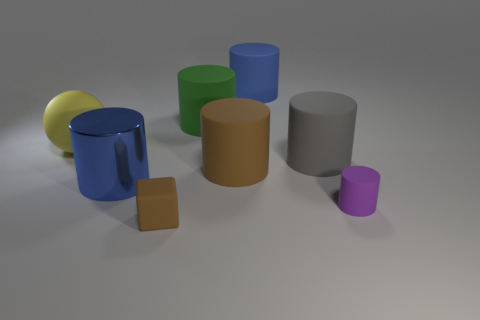Do the tiny rubber object that is on the left side of the gray rubber cylinder and the big rubber object that is in front of the big gray rubber cylinder have the same color?
Give a very brief answer. Yes. What is the material of the gray thing in front of the blue thing behind the blue thing in front of the large blue matte thing?
Provide a succinct answer. Rubber. Are there more shiny things than tiny green rubber spheres?
Keep it short and to the point. Yes. Is there any other thing of the same color as the large metallic object?
Ensure brevity in your answer.  Yes. What size is the purple cylinder that is made of the same material as the green object?
Your answer should be very brief. Small. What material is the large gray cylinder?
Provide a short and direct response. Rubber. What number of green matte things are the same size as the blue rubber cylinder?
Your answer should be compact. 1. The thing that is the same color as the shiny cylinder is what shape?
Provide a short and direct response. Cylinder. Are there any blue objects of the same shape as the green matte object?
Offer a very short reply. Yes. What is the color of the metallic thing that is the same size as the gray matte cylinder?
Provide a short and direct response. Blue. 